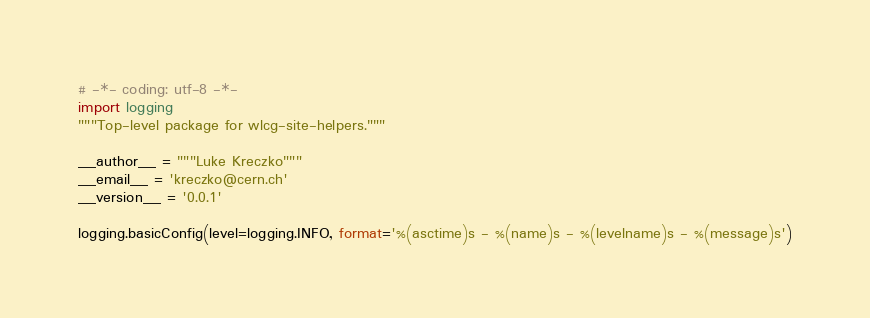<code> <loc_0><loc_0><loc_500><loc_500><_Python_># -*- coding: utf-8 -*-
import logging
"""Top-level package for wlcg-site-helpers."""

__author__ = """Luke Kreczko"""
__email__ = 'kreczko@cern.ch'
__version__ = '0.0.1'

logging.basicConfig(level=logging.INFO, format='%(asctime)s - %(name)s - %(levelname)s - %(message)s')
</code> 